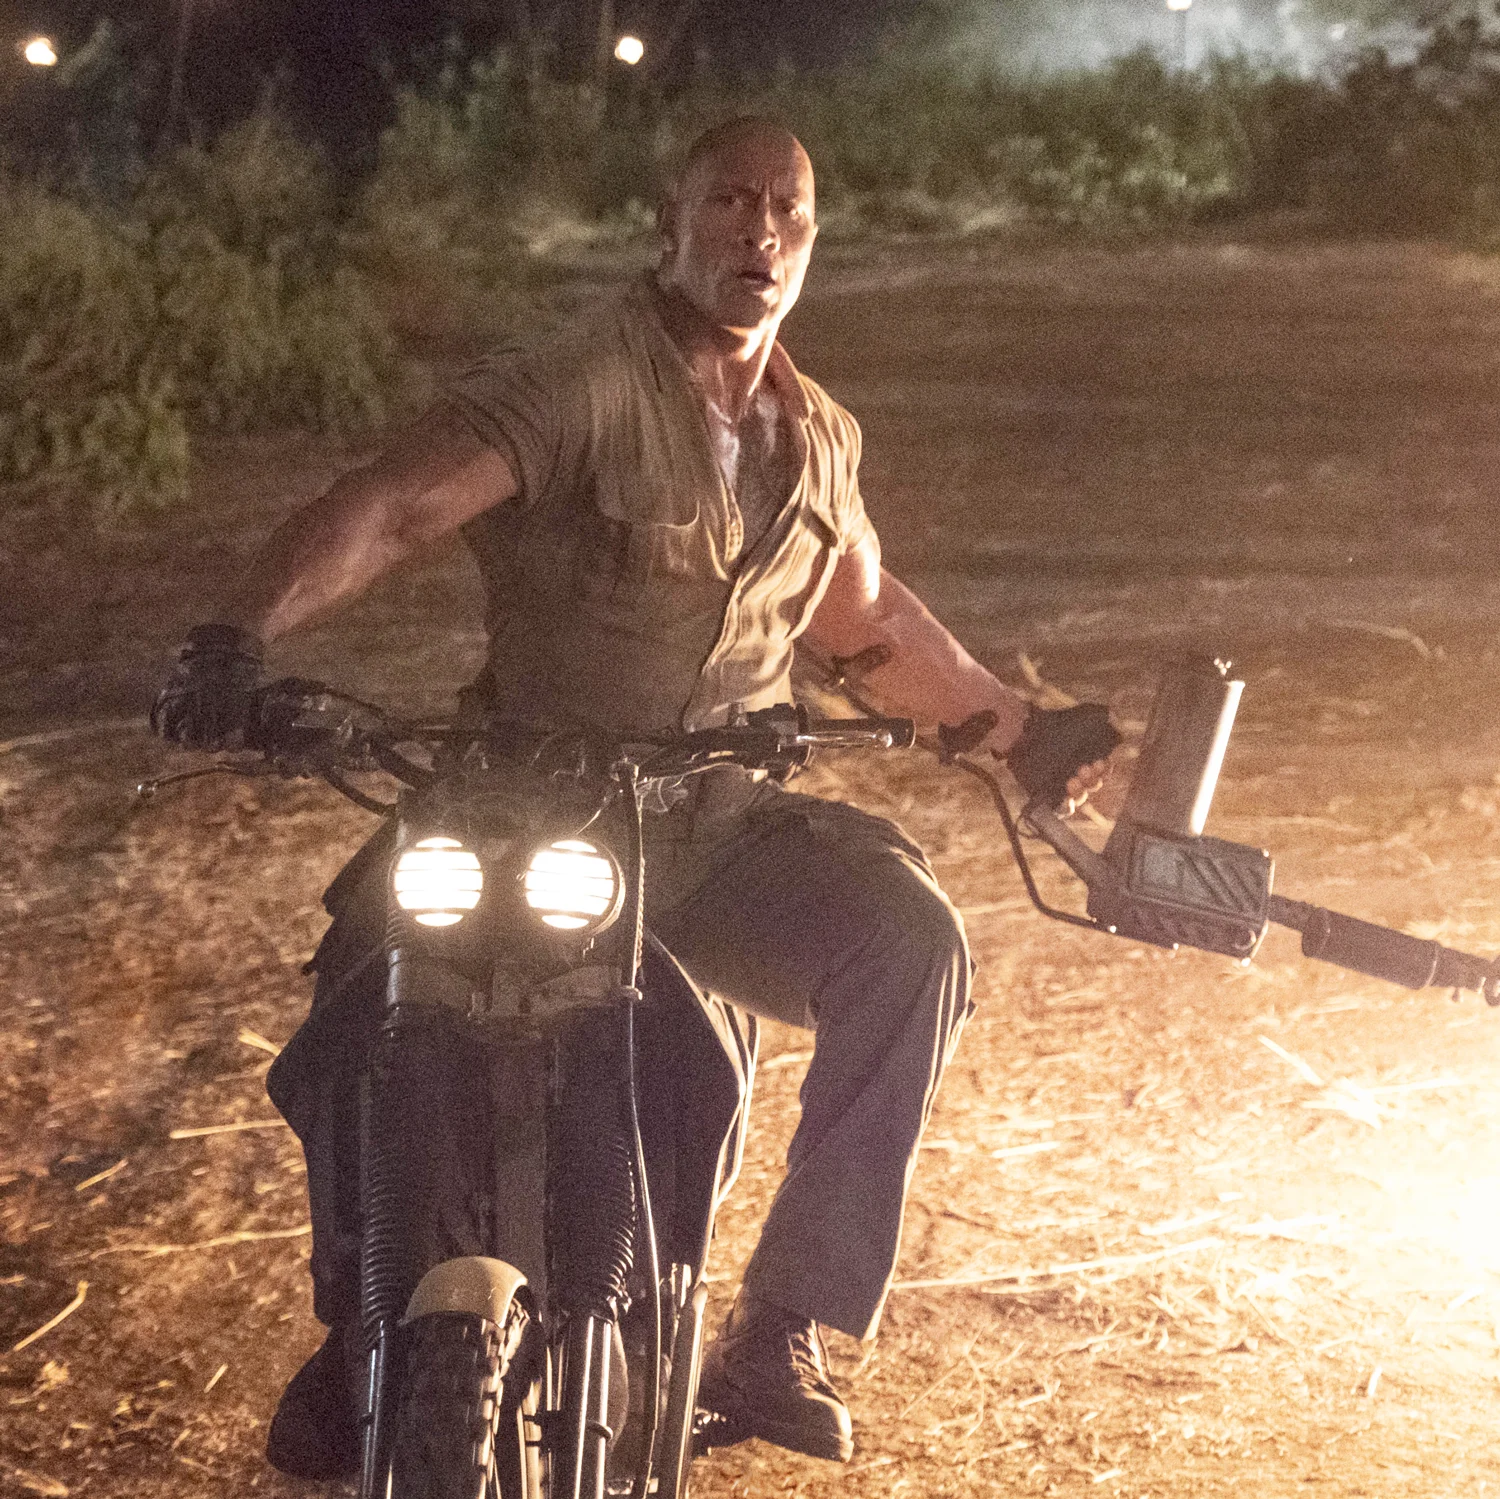Can you describe the main features of this image for me? The image captures an intense and dynamic scene featuring a man, powerfully built, astride a rugged motorcycle. He is dressed in a practical, beige outfit, suitable for action, with his face set in a determined expression. The motorcycle is outfitted with a pair of bright headlights and a large, mounted gun, emphasizing a sense of adventure and danger. Night has fallen, and the dim, natural light casts shadows, enhancing the mood of a high-stakes scenario in a dusty, outdoor setting. The trees and shrubs in the background add to the wilderness feel of the scene. 